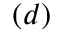Convert formula to latex. <formula><loc_0><loc_0><loc_500><loc_500>( d )</formula> 